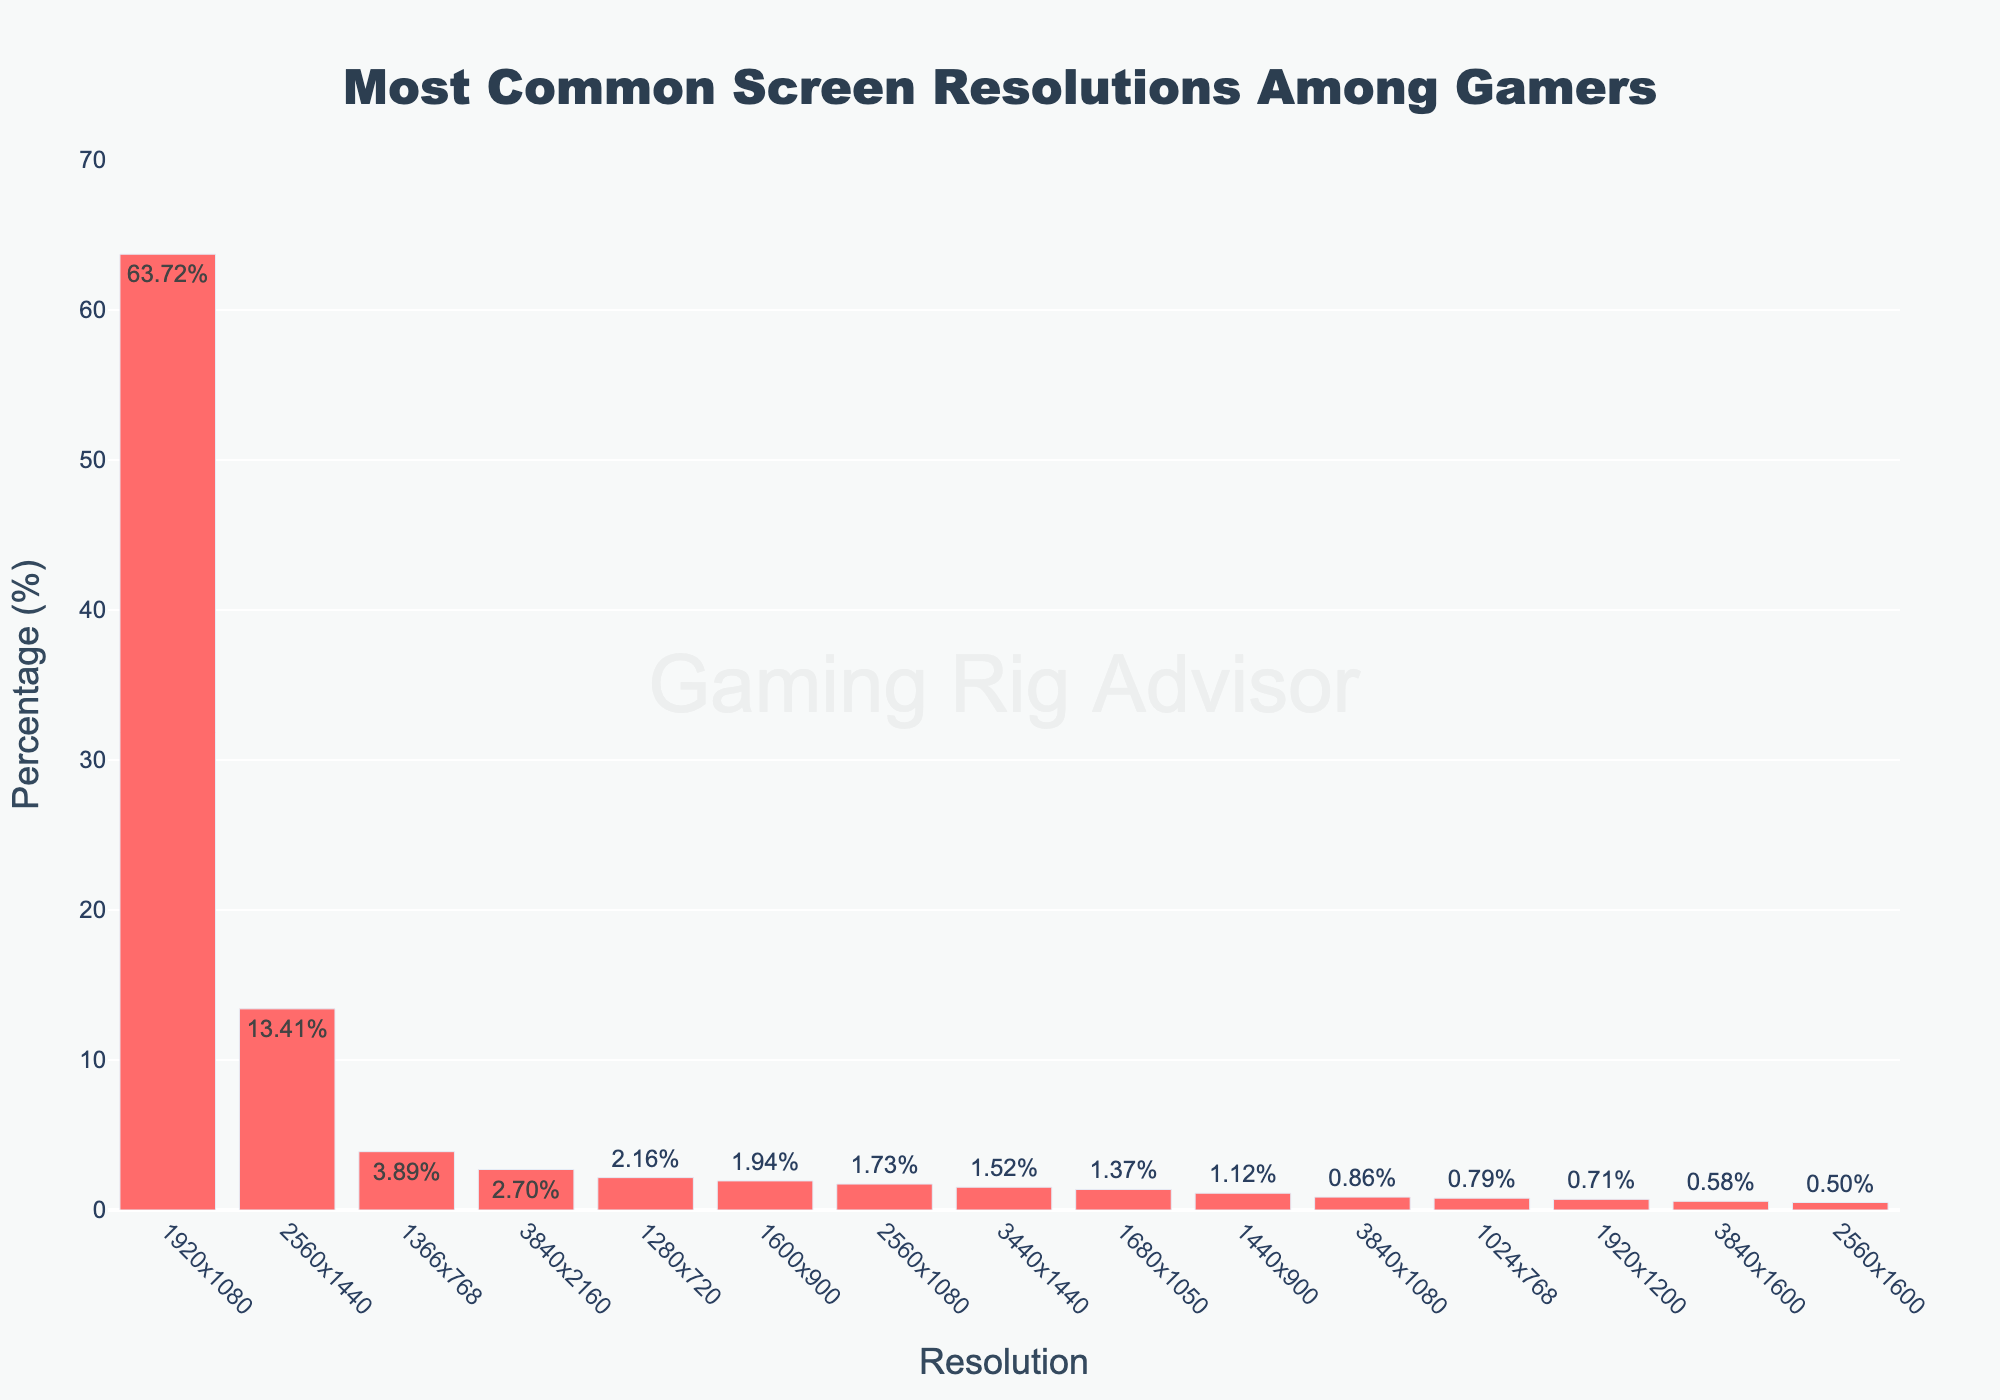What is the highest percentage seen in the bar chart? The highest percentage value in the bar chart represents the most common screen resolution among gamers. By looking at the chart, the tallest bar corresponds to the resolution "1920x1080" with a percentage of 63.72%.
Answer: 63.72% Which screen resolution is the second most common among gamers? In the bar chart, the second tallest bar shows the screen resolution that follows the most popular one. The second tallest bar corresponds to "2560x1440", with a percentage of 13.41%.
Answer: 2560x1440 How much more common is the "1920x1080" resolution compared to "3840x2160"? To find how much more common "1920x1080" is compared to "3840x2160", subtract the percentage of "3840x2160" from "1920x1080". Calculation: 63.72% - 2.70% = 61.02%.
Answer: 61.02% What is the combined percentage of "1366x768", "1280x720", and "1600x900" resolutions? Add the percentages for "1366x768" (3.89%), "1280x720" (2.16%), and "1600x900" (1.94%). Calculation: 3.89% + 2.16% + 1.94% = 7.99%.
Answer: 7.99% Which resolution has the smallest percentage? The bar chart shows various resolutions sorted by their percentages. The shortest bar represents the smallest percentage. The resolution "2560x1600" has the smallest percentage of 0.50%.
Answer: 2560x1600 How many resolutions have a percentage higher than 5%? By visually inspecting the bar lengths, count the number of bars with percentages above 5%. Those resolutions are "1920x1080" and "2560x1440". Thus, there are 2 resolutions with percentages higher than 5%.
Answer: 2 Is the percentage of "1920x1200" greater than or less than 1%? Check where "1920x1200" falls in the bar chart and look at its percentage value. "1920x1200" has a percentage of 0.71%, which is less than 1%.
Answer: Less than 1% What is the average percentage of the resolutions "2560x1080", "3440x1440", and "1680x1050"? Add the percentages for "2560x1080" (1.73%), "3440x1440" (1.52%), and "1680x1050" (1.37%), then divide by 3. Calculation: (1.73% + 1.52% + 1.37%) / 3 = 1.54%.
Answer: 1.54% What is the combined percentage of all resolutions mentioned in the chart? Sum the percentages of all the resolutions listed in the data. Calculations: 63.72% + 13.41% + 2.70% + 3.89% + 2.16% + 1.94% + 1.73% + 1.52% + 1.37% + 1.12% + 0.86% + 0.79% + 0.71% + 0.58% + 0.50% = 97.00%.
Answer: 97.00% 